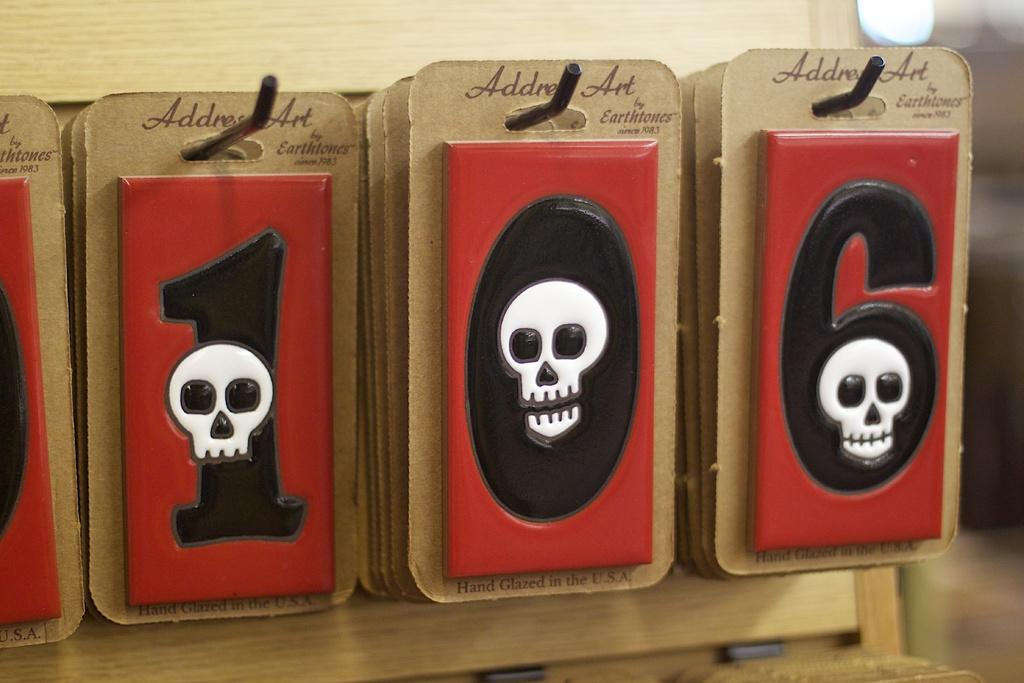What objects are hanging on rods in the image? Number cards are hanged on rods in the image. What additional features can be seen on the number cards? Stickers are present on the number cards. Can you describe the background of the image? The background of the image is blurry. What type of tin can be seen flying in the image? There is no tin present in the image, and no objects are depicted as flying. 